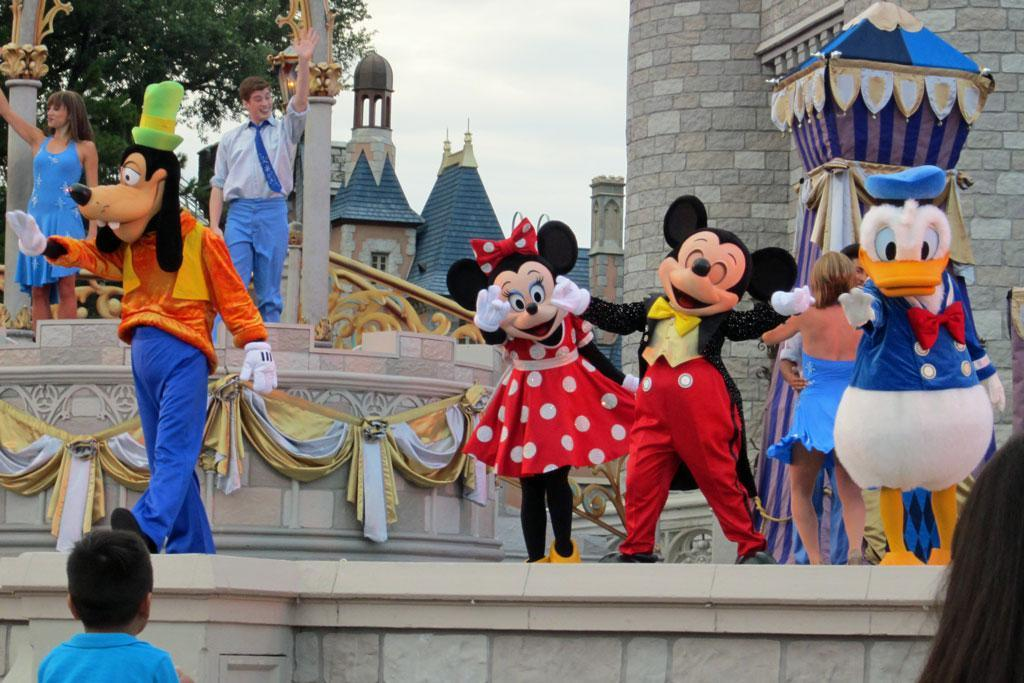How many people are in the image? There are people in the image, but the exact number is not specified. What are the people wearing in the image? The people are wearing costumes in the image. What structure can be seen in the image? There is a tent in the image, as well as walls, pillars, and curtains. What can be seen in the background of the image? In the background of the image, there are trees, buildings, and the sky. What type of circle is being used as a throne in the image? There is no circle or throne present in the image. How does the comparison between the people's costumes and the tent's design contribute to the overall theme of the image? The facts provided do not mention any comparison between the people's costumes and the tent's design, so it is not possible to determine the overall theme of the image based on this information. 